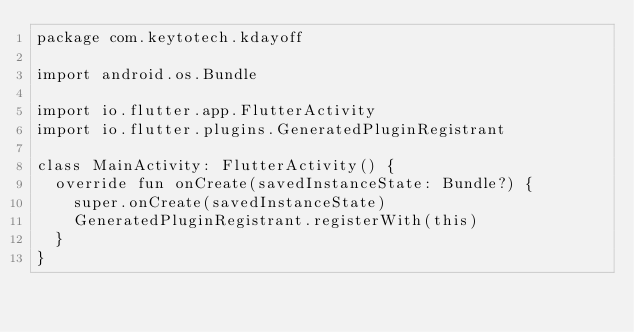<code> <loc_0><loc_0><loc_500><loc_500><_Kotlin_>package com.keytotech.kdayoff

import android.os.Bundle

import io.flutter.app.FlutterActivity
import io.flutter.plugins.GeneratedPluginRegistrant

class MainActivity: FlutterActivity() {
  override fun onCreate(savedInstanceState: Bundle?) {
    super.onCreate(savedInstanceState)
    GeneratedPluginRegistrant.registerWith(this)
  }
}
</code> 